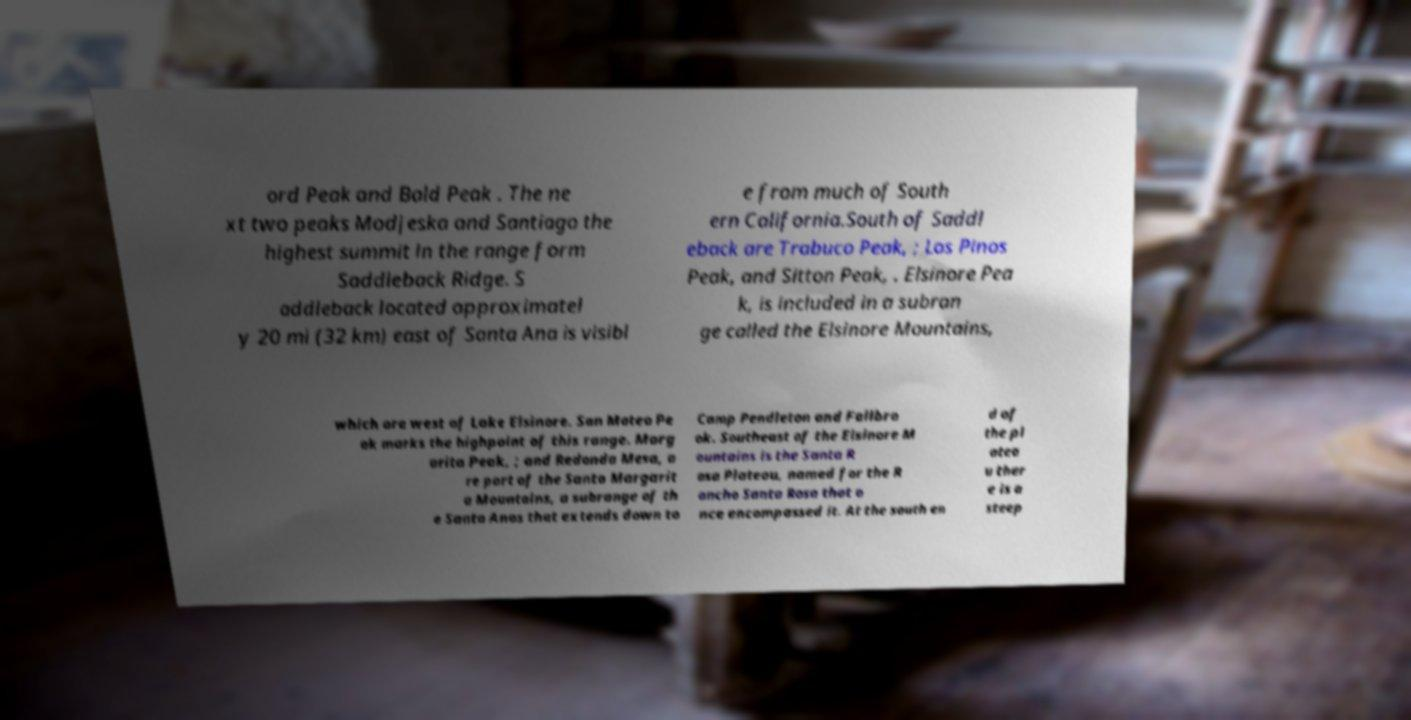Can you accurately transcribe the text from the provided image for me? ord Peak and Bald Peak . The ne xt two peaks Modjeska and Santiago the highest summit in the range form Saddleback Ridge. S addleback located approximatel y 20 mi (32 km) east of Santa Ana is visibl e from much of South ern California.South of Saddl eback are Trabuco Peak, ; Los Pinos Peak, and Sitton Peak, . Elsinore Pea k, is included in a subran ge called the Elsinore Mountains, which are west of Lake Elsinore. San Mateo Pe ak marks the highpoint of this range. Marg arita Peak, ; and Redonda Mesa, a re part of the Santa Margarit a Mountains, a subrange of th e Santa Anas that extends down to Camp Pendleton and Fallbro ok. Southeast of the Elsinore M ountains is the Santa R osa Plateau, named for the R ancho Santa Rosa that o nce encompassed it. At the south en d of the pl atea u ther e is a steep 